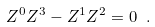<formula> <loc_0><loc_0><loc_500><loc_500>Z ^ { 0 } Z ^ { 3 } - Z ^ { 1 } Z ^ { 2 } = 0 \ .</formula> 